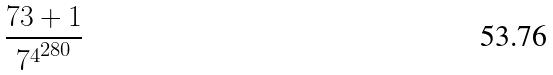<formula> <loc_0><loc_0><loc_500><loc_500>\frac { 7 3 + 1 } { { 7 ^ { 4 } } ^ { 2 8 0 } }</formula> 